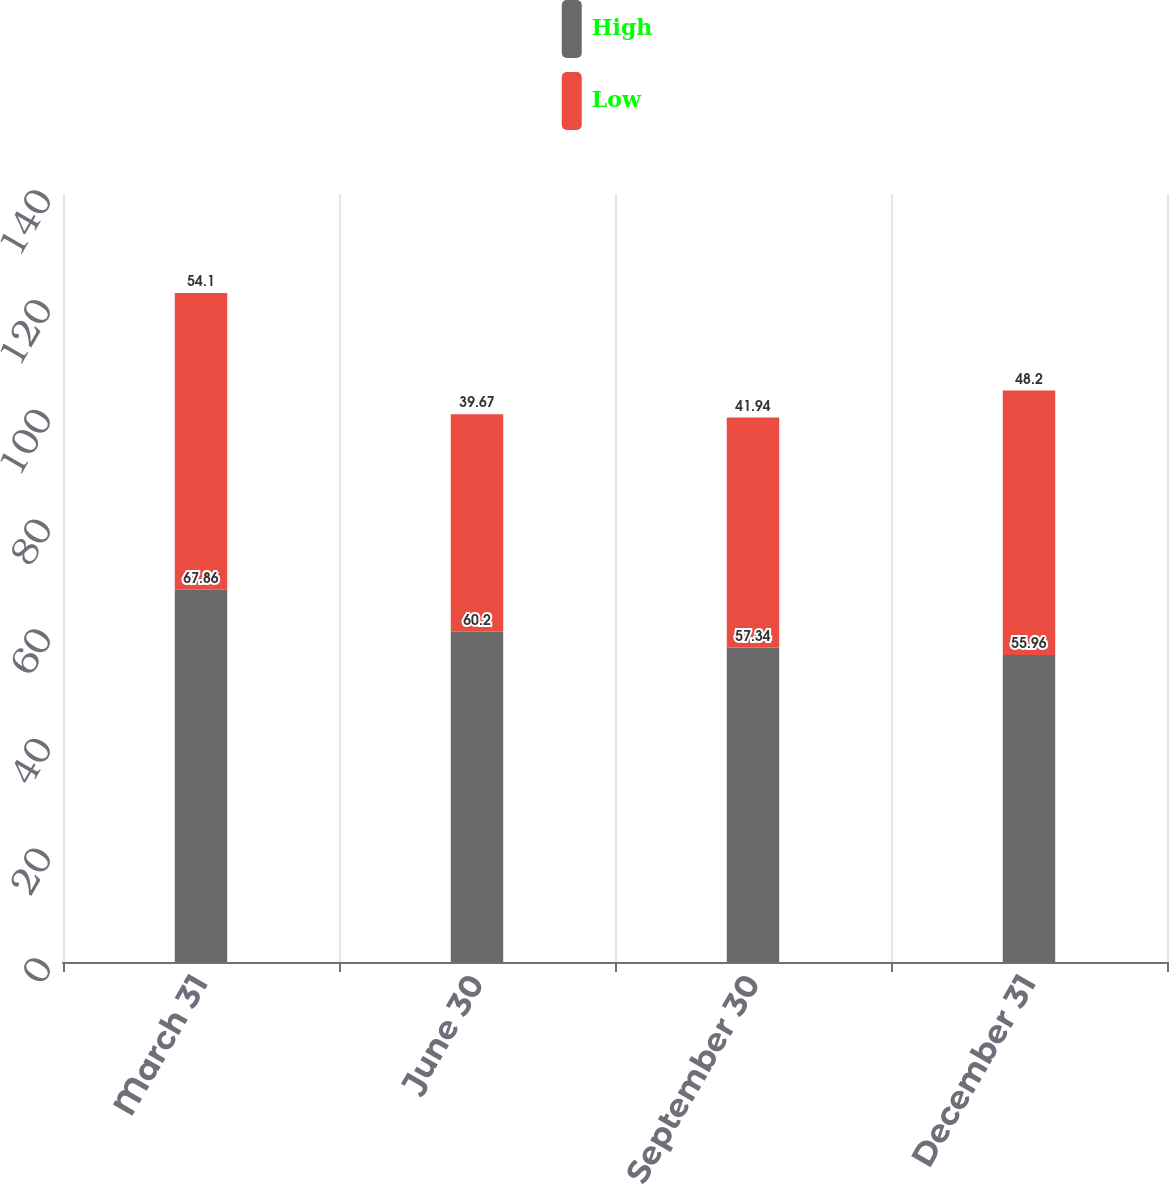<chart> <loc_0><loc_0><loc_500><loc_500><stacked_bar_chart><ecel><fcel>March 31<fcel>June 30<fcel>September 30<fcel>December 31<nl><fcel>High<fcel>67.86<fcel>60.2<fcel>57.34<fcel>55.96<nl><fcel>Low<fcel>54.1<fcel>39.67<fcel>41.94<fcel>48.2<nl></chart> 